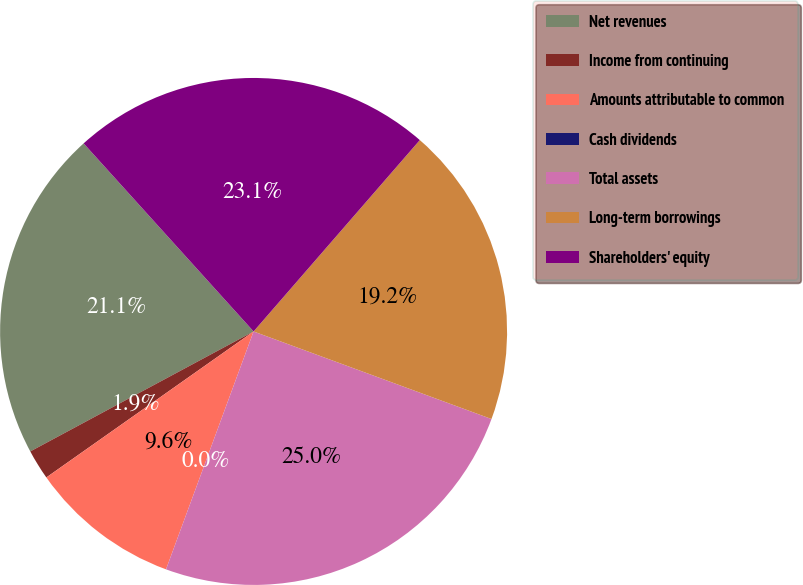<chart> <loc_0><loc_0><loc_500><loc_500><pie_chart><fcel>Net revenues<fcel>Income from continuing<fcel>Amounts attributable to common<fcel>Cash dividends<fcel>Total assets<fcel>Long-term borrowings<fcel>Shareholders' equity<nl><fcel>21.15%<fcel>1.92%<fcel>9.62%<fcel>0.0%<fcel>25.0%<fcel>19.23%<fcel>23.08%<nl></chart> 